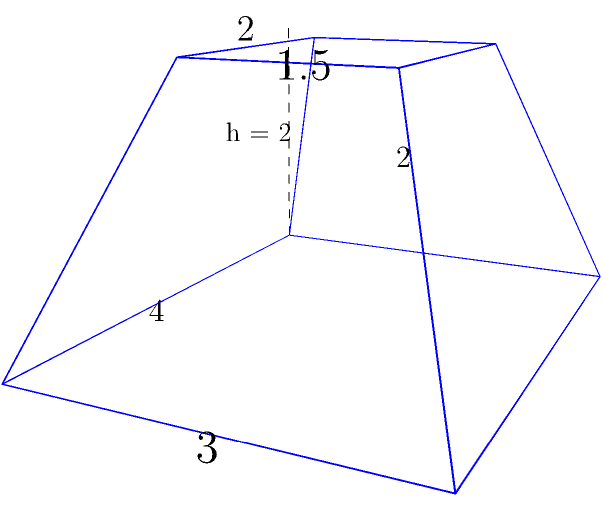In your secluded mountain retreat, you encounter an ancient stone artifact resembling a truncated pyramid. The base measures 4 units by 3 units, while the top surface measures 2 units by 1.5 units. The height of the artifact is 2 units. Calculate the volume of this mysterious truncated pyramid, which might hold the key to decoding your past cryptographic work. To calculate the volume of a truncated pyramid, we'll use the formula:

$$V = \frac{h}{3}(A_1 + A_2 + \sqrt{A_1A_2})$$

Where:
$V$ = volume
$h$ = height
$A_1$ = area of the base
$A_2$ = area of the top surface

Step 1: Calculate the area of the base ($A_1$)
$A_1 = 4 \times 3 = 12$ square units

Step 2: Calculate the area of the top surface ($A_2$)
$A_2 = 2 \times 1.5 = 3$ square units

Step 3: Calculate $\sqrt{A_1A_2}$
$\sqrt{A_1A_2} = \sqrt{12 \times 3} = \sqrt{36} = 6$ square units

Step 4: Apply the formula
$V = \frac{2}{3}(12 + 3 + 6)$
$V = \frac{2}{3}(21)$
$V = 14$ cubic units

Therefore, the volume of the truncated pyramid is 14 cubic units.
Answer: 14 cubic units 